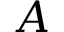<formula> <loc_0><loc_0><loc_500><loc_500>A</formula> 